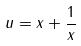Convert formula to latex. <formula><loc_0><loc_0><loc_500><loc_500>u = x + \frac { 1 } { x }</formula> 